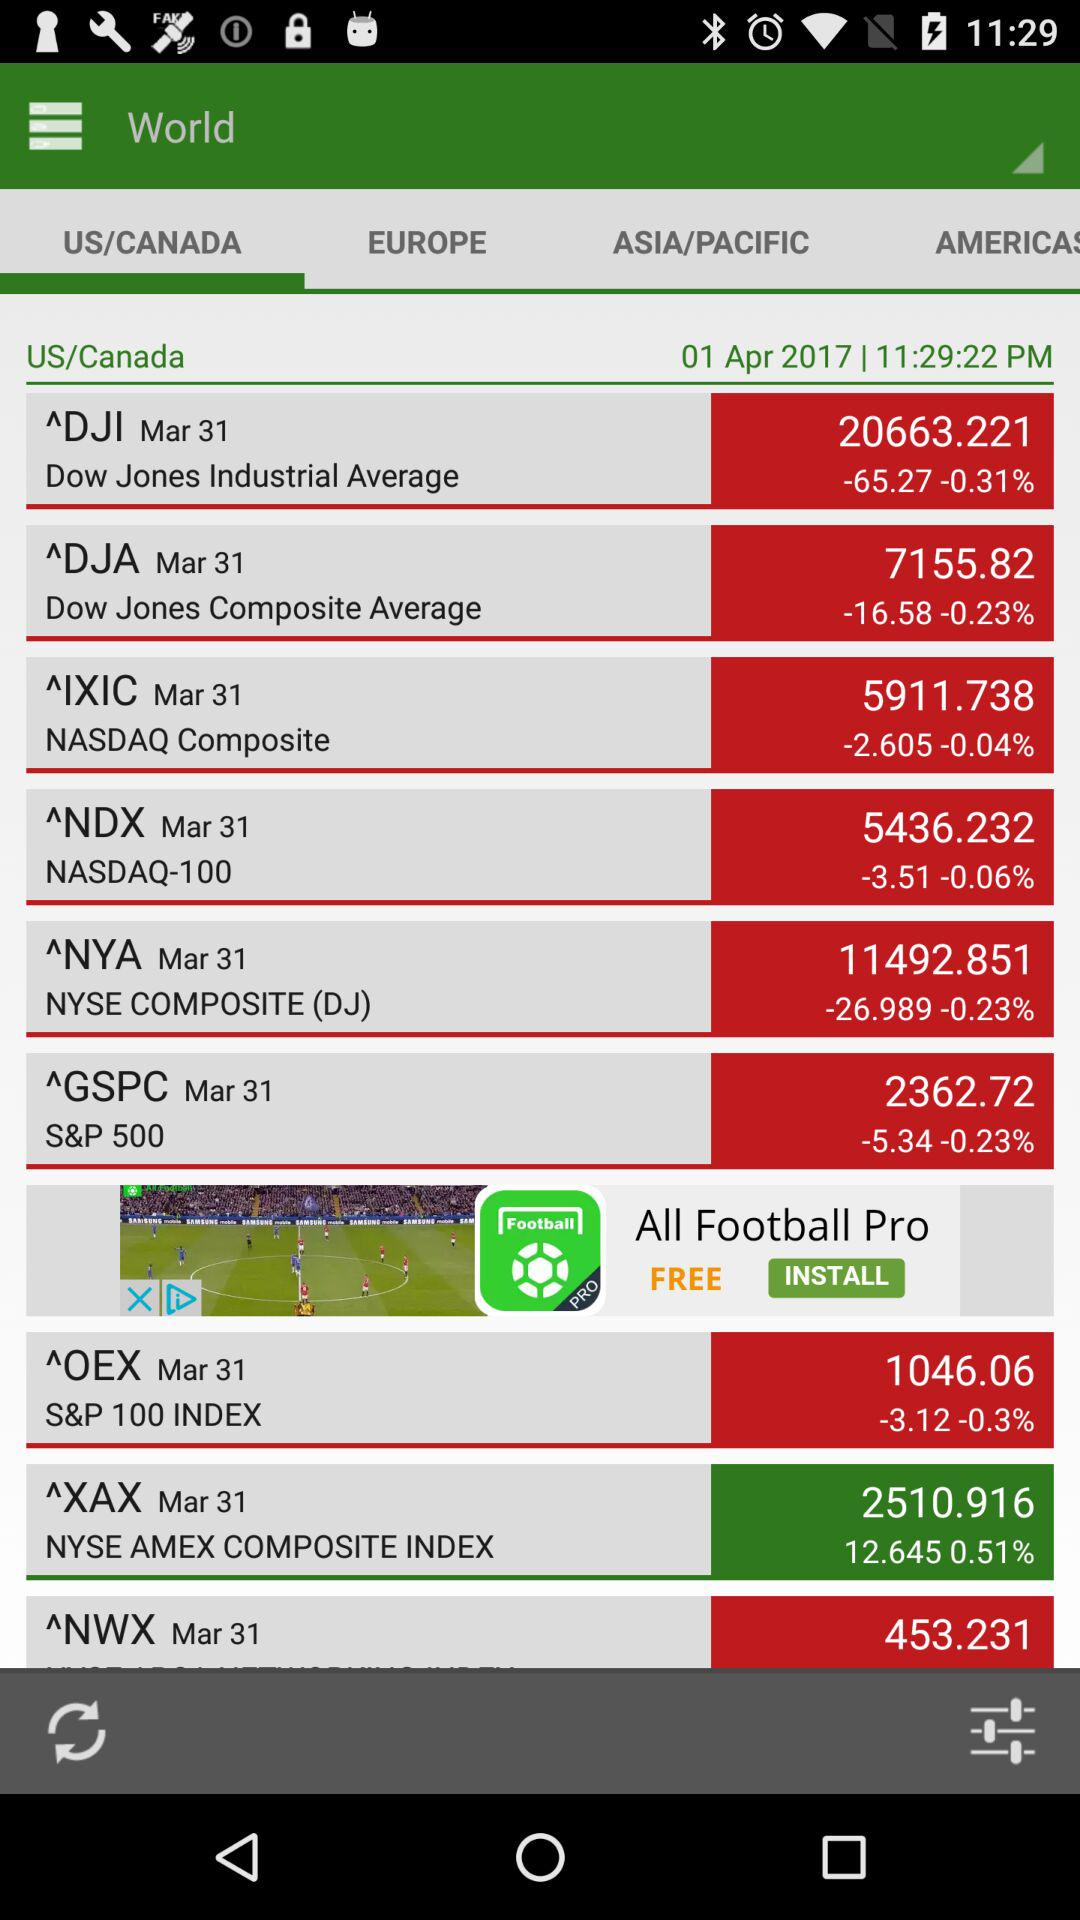How many points did the S&P 500 gain or lose in comparison to its previous value?
Answer the question using a single word or phrase. -5.34 